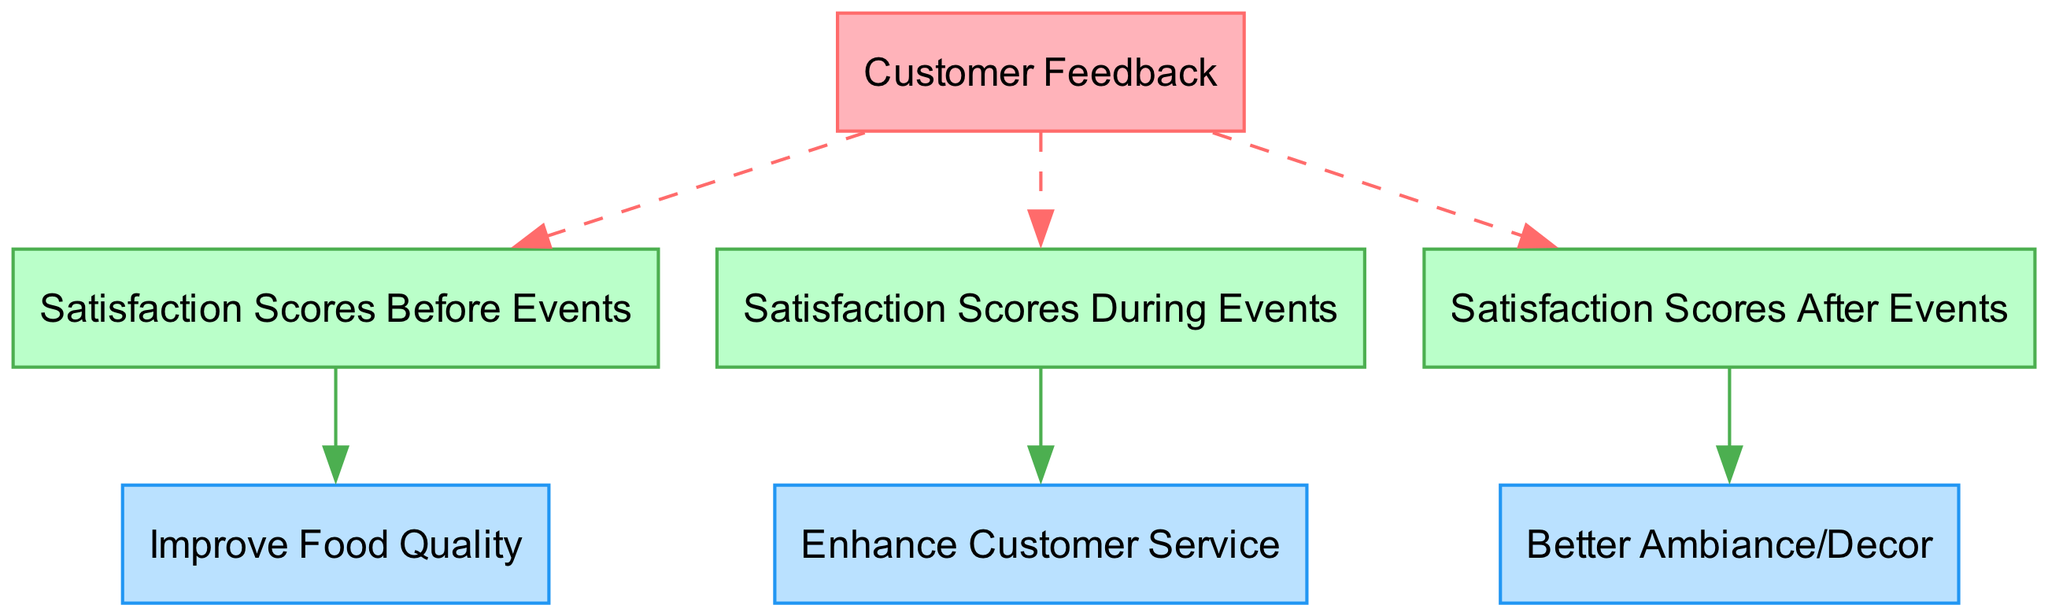What are the satisfaction scores before events linked to? The satisfaction scores before events are linked to customer feedback, which implies that customer feedback influences how satisfied customers are before attending events.
Answer: customer feedback How many improvement suggestions are listed in the diagram? The diagram contains three improvement suggestions that correlate with different satisfaction scores, indicating diverse areas for potential enhancement.
Answer: 3 What type of node is labeled "Satisfaction Scores During Events"? This node represents data, as indicated by its type classification in the diagram's structure.
Answer: data Which improvement suggestion is associated with satisfaction scores after events? After analyzing the edges linked to satisfaction scores after events, it is clear that it correlates with the suggestion to improve ambiance/decor, indicating a specific area for improvement post-event.
Answer: Better Ambiance/Decor What is the relationship between satisfaction scores before events and the improvement suggestion about food quality? The relationship shows that satisfaction scores before events correlate with the suggestion to improve food quality, suggesting a direct influence between these two nodes.
Answer: correlates with Which node is found between the "satisfaction scores during" and "improvement suggestion service"? The improvement suggestion to enhance customer service is positioned between satisfaction scores during events and serves as a response to the feedback gathered during those events.
Answer: Enhance Customer Service What color identifies the improvement suggestion nodes in the diagram? Looking at the node styles specified for improvement suggestions, they are highlighted with a light blue color, which distinguishes them from the other types of nodes.
Answer: light blue How many edges are connected to the “Customer Feedback” node? The diagram outlines three connections stemming from the customer feedback node, linking it to different satisfaction score nodes, demonstrating its central role in the diagram's structure.
Answer: 3 